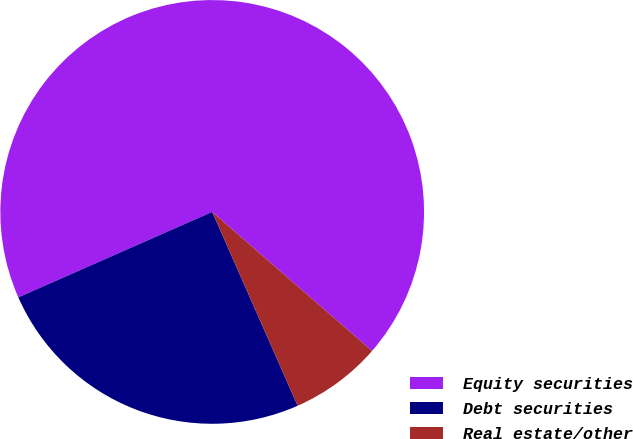<chart> <loc_0><loc_0><loc_500><loc_500><pie_chart><fcel>Equity securities<fcel>Debt securities<fcel>Real estate/other<nl><fcel>68.0%<fcel>25.0%<fcel>7.0%<nl></chart> 